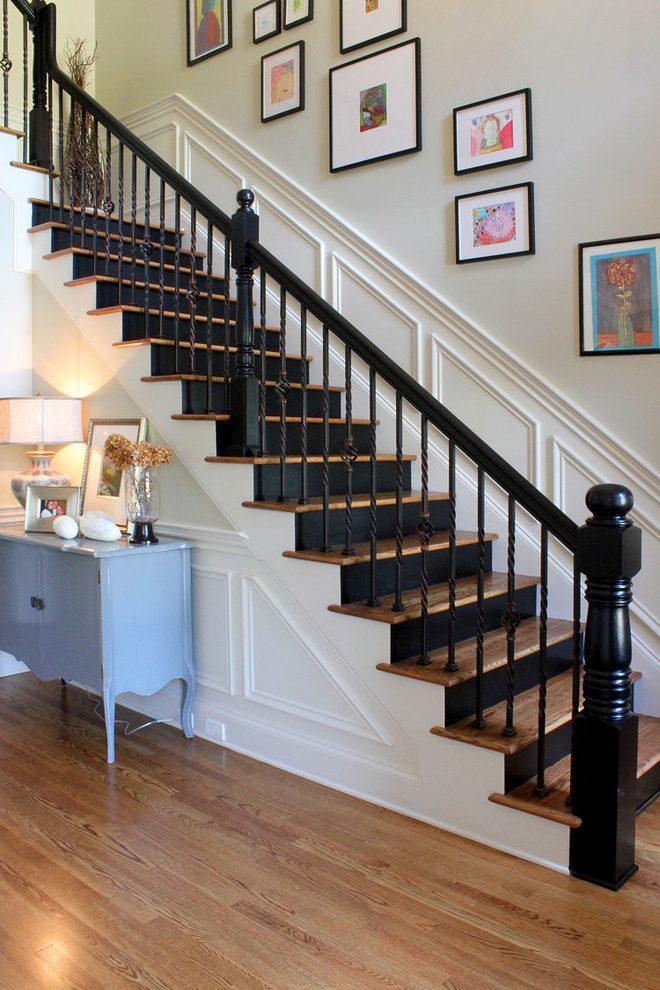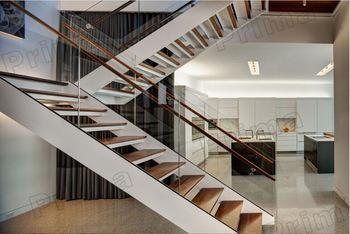The first image is the image on the left, the second image is the image on the right. Considering the images on both sides, is "In at least one image a there are three picture frames showing above a single stair case that faces left with the exception of 1 to 3 individual stairs." valid? Answer yes or no. No. 